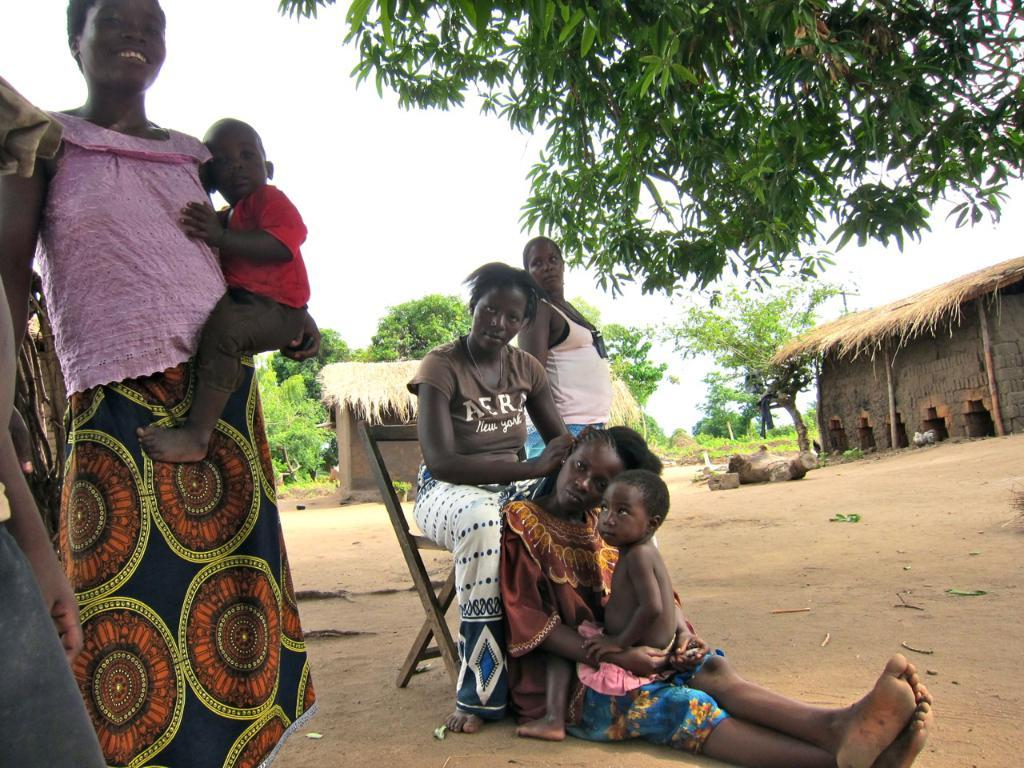Who is present in the image? There are persons in the image, including kids. What type of structures can be seen in the image? There are huts in the image. What type of vegetation is present in the image? There are trees in the image. What is the person in the middle of the image doing? There is a person sitting on a chair in the middle of the image. What is visible at the top of the image? The sky is visible at the top of the image. Where is the playground located in the image? There is no playground present in the image. What type of coast can be seen in the image? There is no coast visible in the image. 